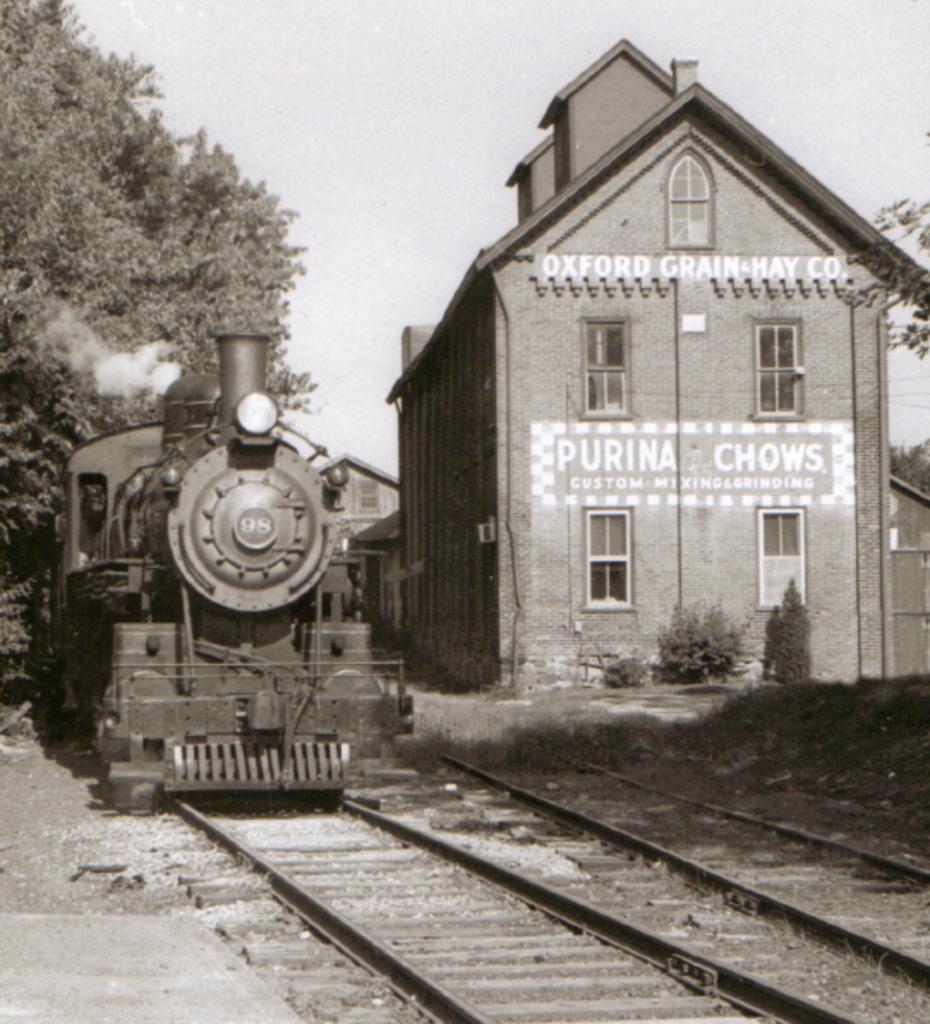Can you describe this image briefly? This is a black and white pic. On the left there is a train on the railway track. On the right there are buildings. In the background there are trees and sky. 